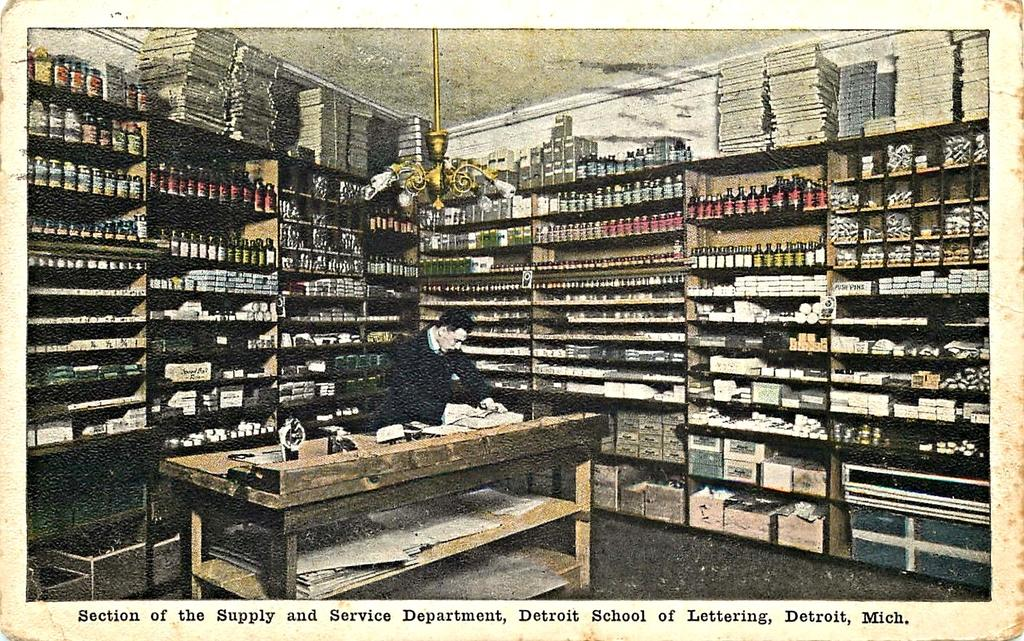<image>
Describe the image concisely. Person in a store with the words "Detroid School of Lettering" on the bottom. 